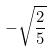<formula> <loc_0><loc_0><loc_500><loc_500>- \sqrt { \frac { 2 } { 5 } }</formula> 